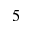Convert formula to latex. <formula><loc_0><loc_0><loc_500><loc_500>5</formula> 